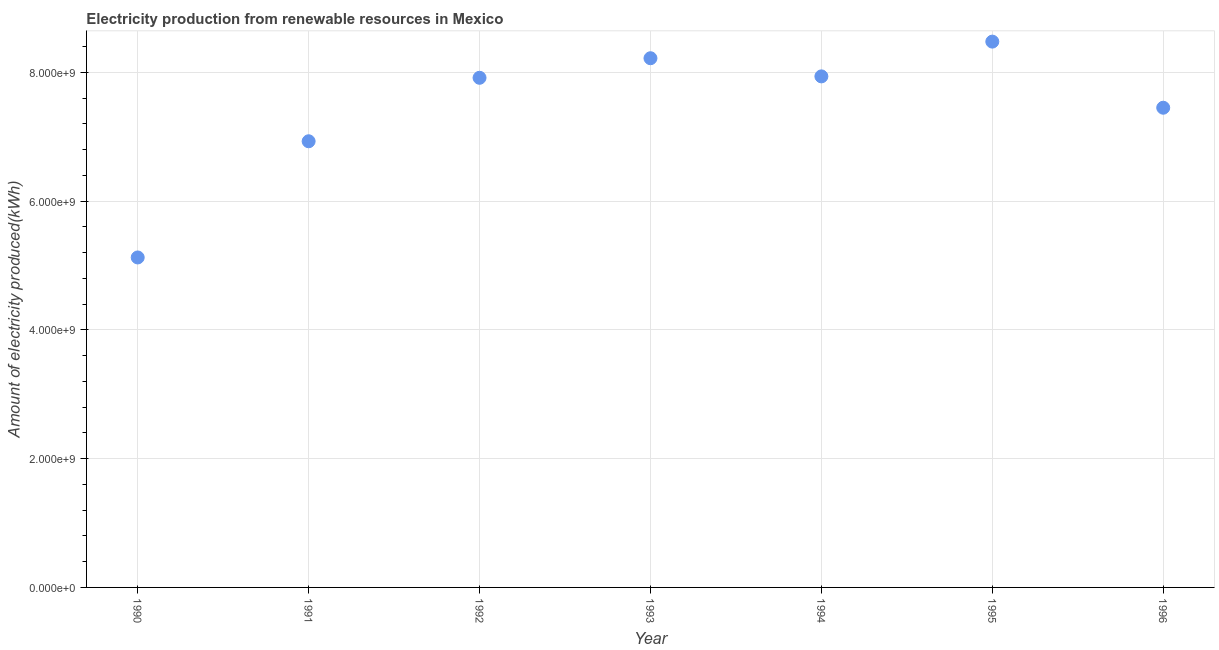What is the amount of electricity produced in 1994?
Keep it short and to the point. 7.94e+09. Across all years, what is the maximum amount of electricity produced?
Ensure brevity in your answer.  8.48e+09. Across all years, what is the minimum amount of electricity produced?
Provide a succinct answer. 5.13e+09. In which year was the amount of electricity produced maximum?
Ensure brevity in your answer.  1995. What is the sum of the amount of electricity produced?
Provide a short and direct response. 5.21e+1. What is the difference between the amount of electricity produced in 1990 and 1993?
Your response must be concise. -3.10e+09. What is the average amount of electricity produced per year?
Keep it short and to the point. 7.44e+09. What is the median amount of electricity produced?
Offer a very short reply. 7.92e+09. In how many years, is the amount of electricity produced greater than 2000000000 kWh?
Provide a short and direct response. 7. Do a majority of the years between 1990 and 1992 (inclusive) have amount of electricity produced greater than 800000000 kWh?
Offer a very short reply. Yes. What is the ratio of the amount of electricity produced in 1991 to that in 1994?
Your answer should be compact. 0.87. Is the amount of electricity produced in 1991 less than that in 1993?
Offer a very short reply. Yes. Is the difference between the amount of electricity produced in 1994 and 1996 greater than the difference between any two years?
Your answer should be compact. No. What is the difference between the highest and the second highest amount of electricity produced?
Provide a short and direct response. 2.58e+08. What is the difference between the highest and the lowest amount of electricity produced?
Ensure brevity in your answer.  3.35e+09. In how many years, is the amount of electricity produced greater than the average amount of electricity produced taken over all years?
Provide a short and direct response. 5. Does the amount of electricity produced monotonically increase over the years?
Your response must be concise. No. What is the title of the graph?
Give a very brief answer. Electricity production from renewable resources in Mexico. What is the label or title of the X-axis?
Keep it short and to the point. Year. What is the label or title of the Y-axis?
Provide a short and direct response. Amount of electricity produced(kWh). What is the Amount of electricity produced(kWh) in 1990?
Offer a very short reply. 5.13e+09. What is the Amount of electricity produced(kWh) in 1991?
Your answer should be compact. 6.93e+09. What is the Amount of electricity produced(kWh) in 1992?
Your answer should be compact. 7.92e+09. What is the Amount of electricity produced(kWh) in 1993?
Your answer should be very brief. 8.22e+09. What is the Amount of electricity produced(kWh) in 1994?
Keep it short and to the point. 7.94e+09. What is the Amount of electricity produced(kWh) in 1995?
Provide a short and direct response. 8.48e+09. What is the Amount of electricity produced(kWh) in 1996?
Offer a terse response. 7.45e+09. What is the difference between the Amount of electricity produced(kWh) in 1990 and 1991?
Offer a terse response. -1.80e+09. What is the difference between the Amount of electricity produced(kWh) in 1990 and 1992?
Make the answer very short. -2.79e+09. What is the difference between the Amount of electricity produced(kWh) in 1990 and 1993?
Keep it short and to the point. -3.10e+09. What is the difference between the Amount of electricity produced(kWh) in 1990 and 1994?
Provide a succinct answer. -2.81e+09. What is the difference between the Amount of electricity produced(kWh) in 1990 and 1995?
Your response must be concise. -3.35e+09. What is the difference between the Amount of electricity produced(kWh) in 1990 and 1996?
Your answer should be very brief. -2.33e+09. What is the difference between the Amount of electricity produced(kWh) in 1991 and 1992?
Your answer should be compact. -9.86e+08. What is the difference between the Amount of electricity produced(kWh) in 1991 and 1993?
Provide a succinct answer. -1.29e+09. What is the difference between the Amount of electricity produced(kWh) in 1991 and 1994?
Your answer should be compact. -1.01e+09. What is the difference between the Amount of electricity produced(kWh) in 1991 and 1995?
Make the answer very short. -1.55e+09. What is the difference between the Amount of electricity produced(kWh) in 1991 and 1996?
Offer a very short reply. -5.21e+08. What is the difference between the Amount of electricity produced(kWh) in 1992 and 1993?
Offer a very short reply. -3.04e+08. What is the difference between the Amount of electricity produced(kWh) in 1992 and 1994?
Your answer should be very brief. -2.20e+07. What is the difference between the Amount of electricity produced(kWh) in 1992 and 1995?
Your answer should be compact. -5.62e+08. What is the difference between the Amount of electricity produced(kWh) in 1992 and 1996?
Provide a succinct answer. 4.65e+08. What is the difference between the Amount of electricity produced(kWh) in 1993 and 1994?
Ensure brevity in your answer.  2.82e+08. What is the difference between the Amount of electricity produced(kWh) in 1993 and 1995?
Keep it short and to the point. -2.58e+08. What is the difference between the Amount of electricity produced(kWh) in 1993 and 1996?
Your answer should be very brief. 7.69e+08. What is the difference between the Amount of electricity produced(kWh) in 1994 and 1995?
Ensure brevity in your answer.  -5.40e+08. What is the difference between the Amount of electricity produced(kWh) in 1994 and 1996?
Offer a very short reply. 4.87e+08. What is the difference between the Amount of electricity produced(kWh) in 1995 and 1996?
Provide a short and direct response. 1.03e+09. What is the ratio of the Amount of electricity produced(kWh) in 1990 to that in 1991?
Give a very brief answer. 0.74. What is the ratio of the Amount of electricity produced(kWh) in 1990 to that in 1992?
Provide a succinct answer. 0.65. What is the ratio of the Amount of electricity produced(kWh) in 1990 to that in 1993?
Your response must be concise. 0.62. What is the ratio of the Amount of electricity produced(kWh) in 1990 to that in 1994?
Keep it short and to the point. 0.65. What is the ratio of the Amount of electricity produced(kWh) in 1990 to that in 1995?
Your response must be concise. 0.6. What is the ratio of the Amount of electricity produced(kWh) in 1990 to that in 1996?
Your answer should be compact. 0.69. What is the ratio of the Amount of electricity produced(kWh) in 1991 to that in 1993?
Your answer should be compact. 0.84. What is the ratio of the Amount of electricity produced(kWh) in 1991 to that in 1994?
Offer a very short reply. 0.87. What is the ratio of the Amount of electricity produced(kWh) in 1991 to that in 1995?
Provide a succinct answer. 0.82. What is the ratio of the Amount of electricity produced(kWh) in 1992 to that in 1993?
Offer a terse response. 0.96. What is the ratio of the Amount of electricity produced(kWh) in 1992 to that in 1994?
Provide a short and direct response. 1. What is the ratio of the Amount of electricity produced(kWh) in 1992 to that in 1995?
Keep it short and to the point. 0.93. What is the ratio of the Amount of electricity produced(kWh) in 1992 to that in 1996?
Offer a very short reply. 1.06. What is the ratio of the Amount of electricity produced(kWh) in 1993 to that in 1994?
Offer a terse response. 1.04. What is the ratio of the Amount of electricity produced(kWh) in 1993 to that in 1995?
Provide a succinct answer. 0.97. What is the ratio of the Amount of electricity produced(kWh) in 1993 to that in 1996?
Your answer should be very brief. 1.1. What is the ratio of the Amount of electricity produced(kWh) in 1994 to that in 1995?
Ensure brevity in your answer.  0.94. What is the ratio of the Amount of electricity produced(kWh) in 1994 to that in 1996?
Keep it short and to the point. 1.06. What is the ratio of the Amount of electricity produced(kWh) in 1995 to that in 1996?
Provide a short and direct response. 1.14. 